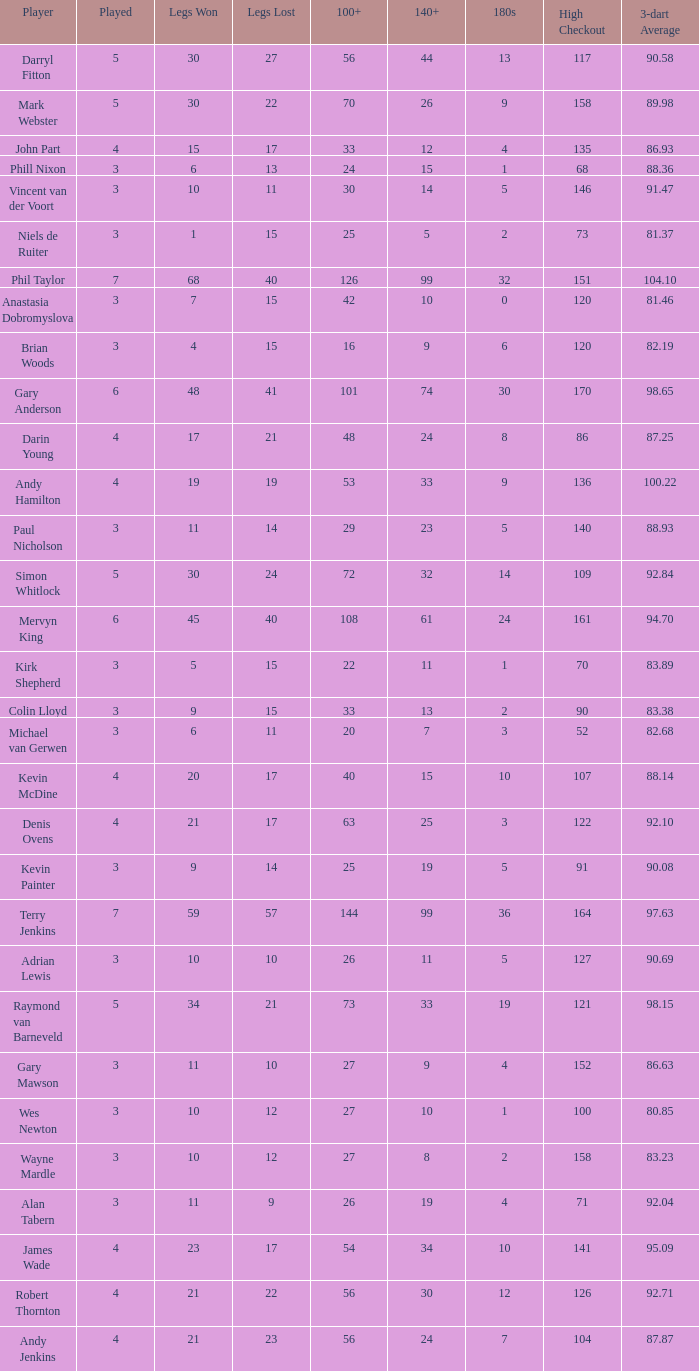Who is the player with 41 legs lost? Gary Anderson. 